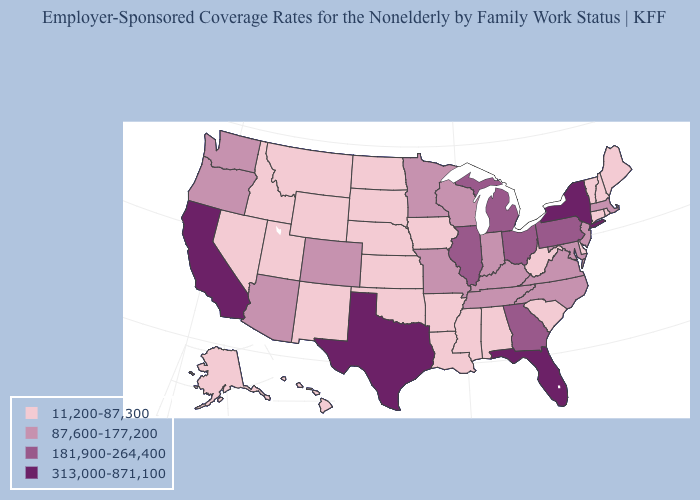Does Massachusetts have a lower value than Vermont?
Give a very brief answer. No. Which states have the lowest value in the Northeast?
Be succinct. Connecticut, Maine, New Hampshire, Rhode Island, Vermont. Name the states that have a value in the range 11,200-87,300?
Write a very short answer. Alabama, Alaska, Arkansas, Connecticut, Delaware, Hawaii, Idaho, Iowa, Kansas, Louisiana, Maine, Mississippi, Montana, Nebraska, Nevada, New Hampshire, New Mexico, North Dakota, Oklahoma, Rhode Island, South Carolina, South Dakota, Utah, Vermont, West Virginia, Wyoming. What is the highest value in the USA?
Be succinct. 313,000-871,100. Does the map have missing data?
Be succinct. No. Among the states that border Mississippi , which have the lowest value?
Concise answer only. Alabama, Arkansas, Louisiana. How many symbols are there in the legend?
Give a very brief answer. 4. What is the value of Idaho?
Short answer required. 11,200-87,300. Among the states that border Ohio , does Pennsylvania have the lowest value?
Write a very short answer. No. Among the states that border Nevada , which have the lowest value?
Quick response, please. Idaho, Utah. Name the states that have a value in the range 313,000-871,100?
Concise answer only. California, Florida, New York, Texas. Among the states that border Iowa , which have the highest value?
Be succinct. Illinois. Which states have the lowest value in the MidWest?
Concise answer only. Iowa, Kansas, Nebraska, North Dakota, South Dakota. How many symbols are there in the legend?
Be succinct. 4. Does Oregon have a higher value than Minnesota?
Concise answer only. No. 